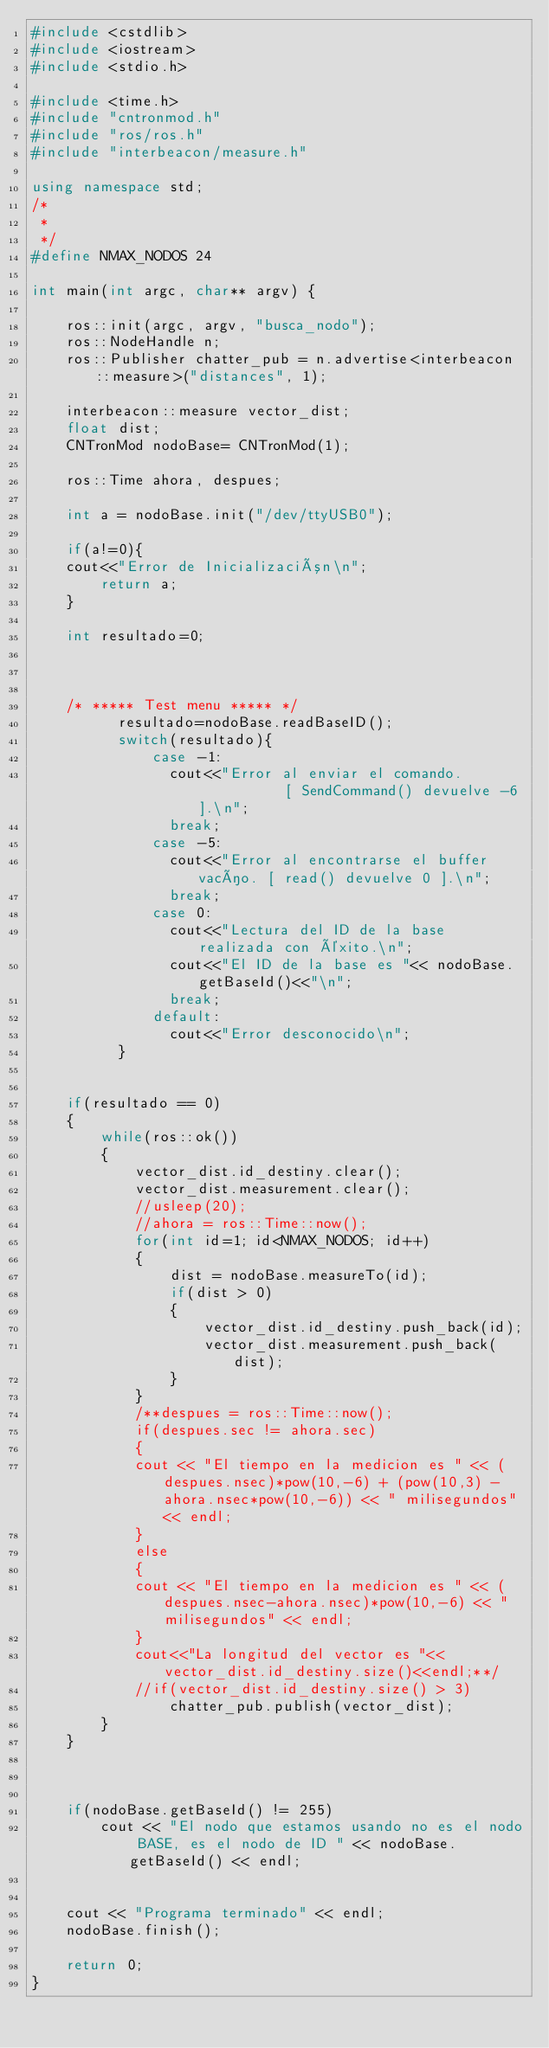Convert code to text. <code><loc_0><loc_0><loc_500><loc_500><_C++_>#include <cstdlib>
#include <iostream>
#include <stdio.h>

#include <time.h>
#include "cntronmod.h"
#include "ros/ros.h"
#include "interbeacon/measure.h"

using namespace std;
/*
 * 
 */
#define NMAX_NODOS 24

int main(int argc, char** argv) {

    ros::init(argc, argv, "busca_nodo");
    ros::NodeHandle n;
    ros::Publisher chatter_pub = n.advertise<interbeacon::measure>("distances", 1);

    interbeacon::measure vector_dist;
    float dist;
    CNTronMod nodoBase= CNTronMod(1);

	ros::Time ahora, despues;

    int a = nodoBase.init("/dev/ttyUSB0");

    if(a!=0){
	cout<<"Error de Inicialización\n";
        return a;
    }

    int resultado=0;
    

    
    /* ***** Test menu ***** */
          resultado=nodoBase.readBaseID();
          switch(resultado){
              case -1:
                cout<<"Error al enviar el comando.           [ SendCommand() devuelve -6 ].\n";
                break;
              case -5:
                cout<<"Error al encontrarse el buffer vacío. [ read() devuelve 0 ].\n";
                break;
              case 0:
                cout<<"Lectura del ID de la base realizada con éxito.\n";
                cout<<"El ID de la base es "<< nodoBase.getBaseId()<<"\n";
                break;
              default:
                cout<<"Error desconocido\n";
          }
	

    if(resultado == 0)
	{
		while(ros::ok())
		{
			vector_dist.id_destiny.clear();
			vector_dist.measurement.clear();
			//usleep(20);
			//ahora = ros::Time::now();			
			for(int id=1; id<NMAX_NODOS; id++)
			{
				dist = nodoBase.measureTo(id);
	  			if(dist > 0)
				{
					vector_dist.id_destiny.push_back(id);
					vector_dist.measurement.push_back(dist);
				}
			}
			/**despues = ros::Time::now();
			if(despues.sec != ahora.sec)
			{
			cout << "El tiempo en la medicion es " << (despues.nsec)*pow(10,-6) + (pow(10,3) - ahora.nsec*pow(10,-6)) << " milisegundos" << endl;
			}
			else
			{
			cout << "El tiempo en la medicion es " << (despues.nsec-ahora.nsec)*pow(10,-6) << " milisegundos" << endl;
			}
			cout<<"La longitud del vector es "<<vector_dist.id_destiny.size()<<endl;**/
            //if(vector_dist.id_destiny.size() > 3)
                chatter_pub.publish(vector_dist);
		}		
	}



	if(nodoBase.getBaseId() != 255)
		cout << "El nodo que estamos usando no es el nodo BASE, es el nodo de ID " << nodoBase.getBaseId() << endl;


    cout << "Programa terminado" << endl;
    nodoBase.finish();

    return 0;
}


</code> 